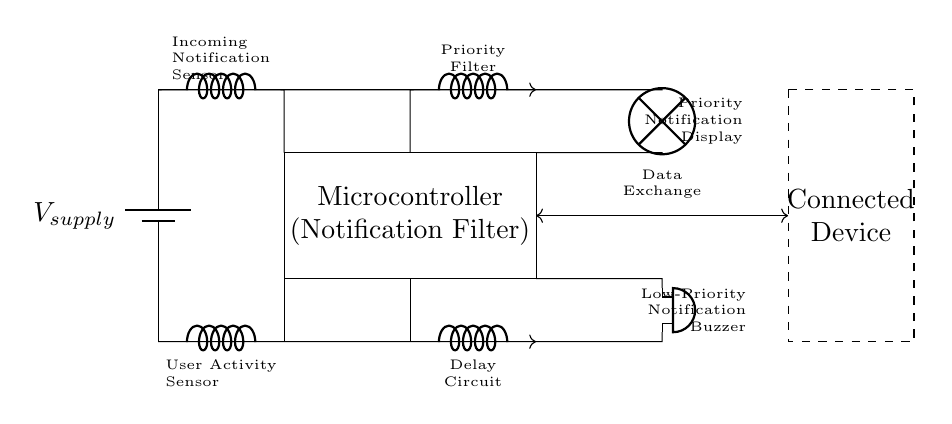What is the main component used for filtering notifications? The main component is the microcontroller, which serves as the notification filter and processes incoming notifications based on user activity.
Answer: microcontroller What type of notifications does the priority filter handle? The priority filter handles incoming notifications and determines which ones are important enough to be displayed, allowing users to focus on high-priority messages.
Answer: priority notifications What kind of device is connected to the circuit? The connected device is an industrial appliance, which interacts with the automated notification filtering system for reducing distractions.
Answer: Connected Device What function does the user activity sensor serve? The user activity sensor detects whether the user is currently engaged with their device, allowing the system to filter notifications appropriately based on this activity.
Answer: Detection of user activity How does a low-priority notification get communicated in this circuit? A low-priority notification is communicated via a buzzer which activates only if the user is not engaged, providing a non-intrusive method of alerting the user.
Answer: buzzer What is the role of the delay circuit in this system? The delay circuit adds a timed interval before handling low-priority notifications, ensuring that they do not interrupt the user unnecessarily during periods of activity.
Answer: Delay in handling notifications Which element represents the source of power for the circuit? The source of power for the circuit is represented by a battery, which supplies the necessary voltage for the operation of the devices and components within the circuit.
Answer: battery 